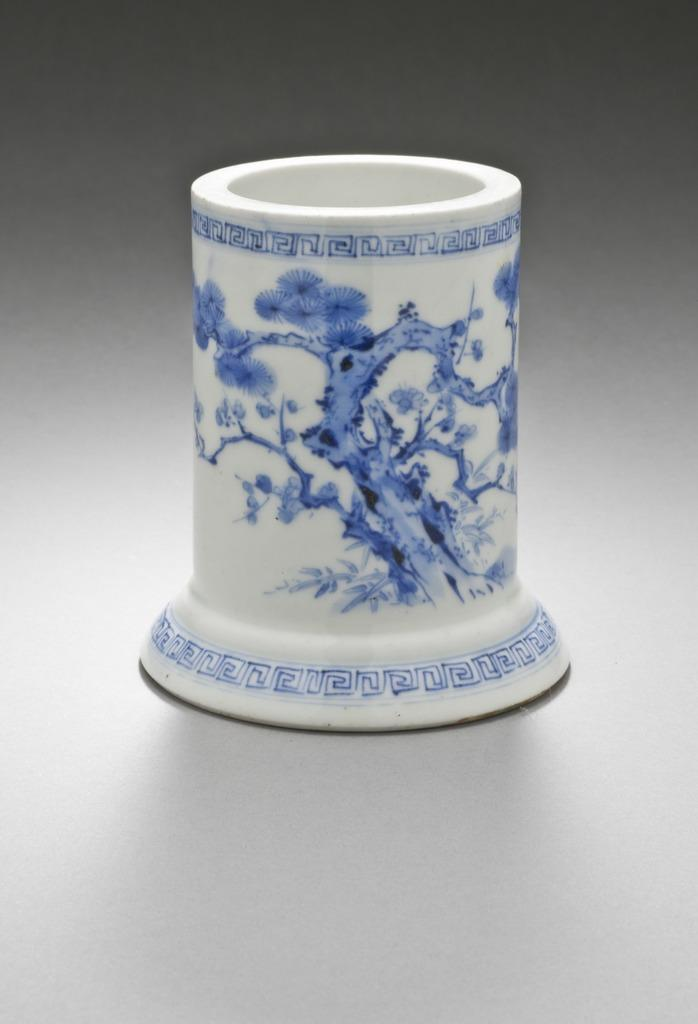What object is the main focus of the image? The main focus of the image is a cylindrical brush holder. What is unique about the base of the brush holder? The brush holder has a flared base. What colors are used to design the brush holder? The brush holder is in blue and white color. What color is the background of the image? The background of the image is grey in color. How many pickles are in the sink in the image? There is no sink or pickles present in the image. 